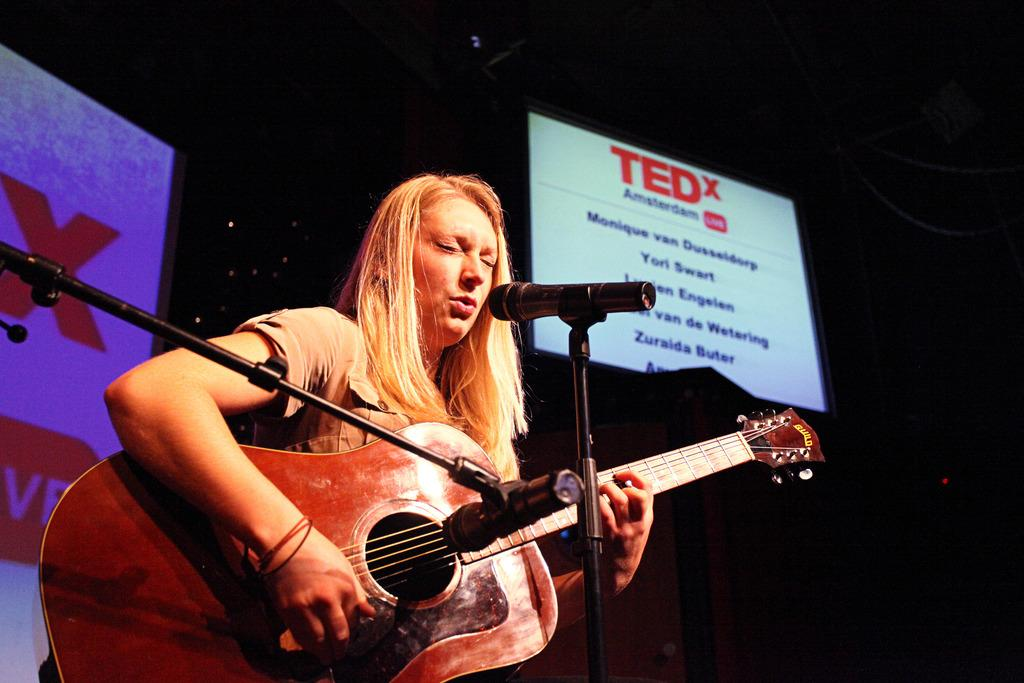Who is the main subject in the image? There is a woman in the image. What is the woman doing in the image? The woman is standing and playing a guitar. What object is in front of the woman? There is a microphone in front of the woman. What else can be seen in the image? There are boards visible in the image. What type of appliance is the woman using to cook in the image? There is no appliance visible in the image, and the woman is not cooking; she is playing a guitar. What part of the woman's body is exposed in the image? The image does not show any exposed flesh; the woman is fully clothed while playing the guitar. 